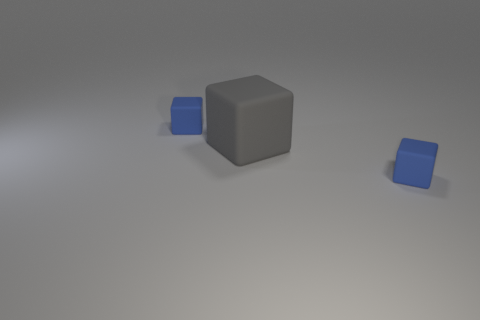Add 2 gray cylinders. How many objects exist? 5 Subtract all tiny blue rubber blocks. How many blocks are left? 1 Subtract all blue cubes. How many cubes are left? 1 Subtract all gray cylinders. How many blue cubes are left? 2 Subtract 1 blocks. How many blocks are left? 2 Subtract all big gray objects. Subtract all small purple metallic objects. How many objects are left? 2 Add 2 large gray rubber cubes. How many large gray rubber cubes are left? 3 Add 2 tiny red rubber cubes. How many tiny red rubber cubes exist? 2 Subtract 0 yellow cubes. How many objects are left? 3 Subtract all green blocks. Subtract all yellow balls. How many blocks are left? 3 